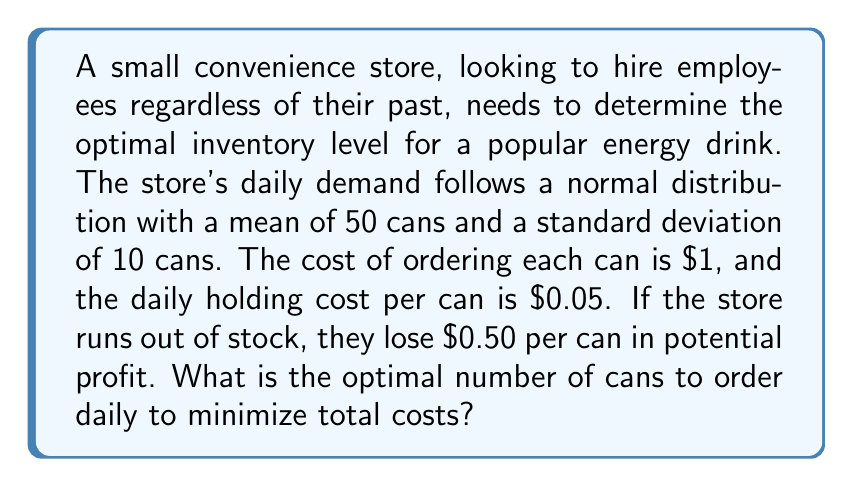Can you answer this question? To solve this problem, we'll use the newsvendor model, which is appropriate for determining optimal inventory levels under uncertain demand.

Step 1: Calculate the critical fractile (CF)
CF = $\frac{\text{Underage Cost}}{\text{Underage Cost + Overage Cost}}$

Underage Cost = Lost profit per can = $0.50
Overage Cost = Holding cost per can = $0.05

CF = $\frac{0.50}{0.50 + 0.05} = \frac{0.50}{0.55} \approx 0.9091$

Step 2: Find the z-score corresponding to the critical fractile
Using a standard normal distribution table or calculator, we find that the z-score for 0.9091 is approximately 1.34.

Step 3: Calculate the optimal inventory level
Optimal Inventory = $\mu + z\sigma$

Where:
$\mu$ = mean demand = 50 cans
$\sigma$ = standard deviation of demand = 10 cans
$z$ = z-score = 1.34

Optimal Inventory = $50 + (1.34 \times 10) = 50 + 13.4 = 63.4$

Step 4: Round to the nearest whole number
Since we can't order fractional cans, we round to the nearest integer: 63 cans.
Answer: 63 cans 